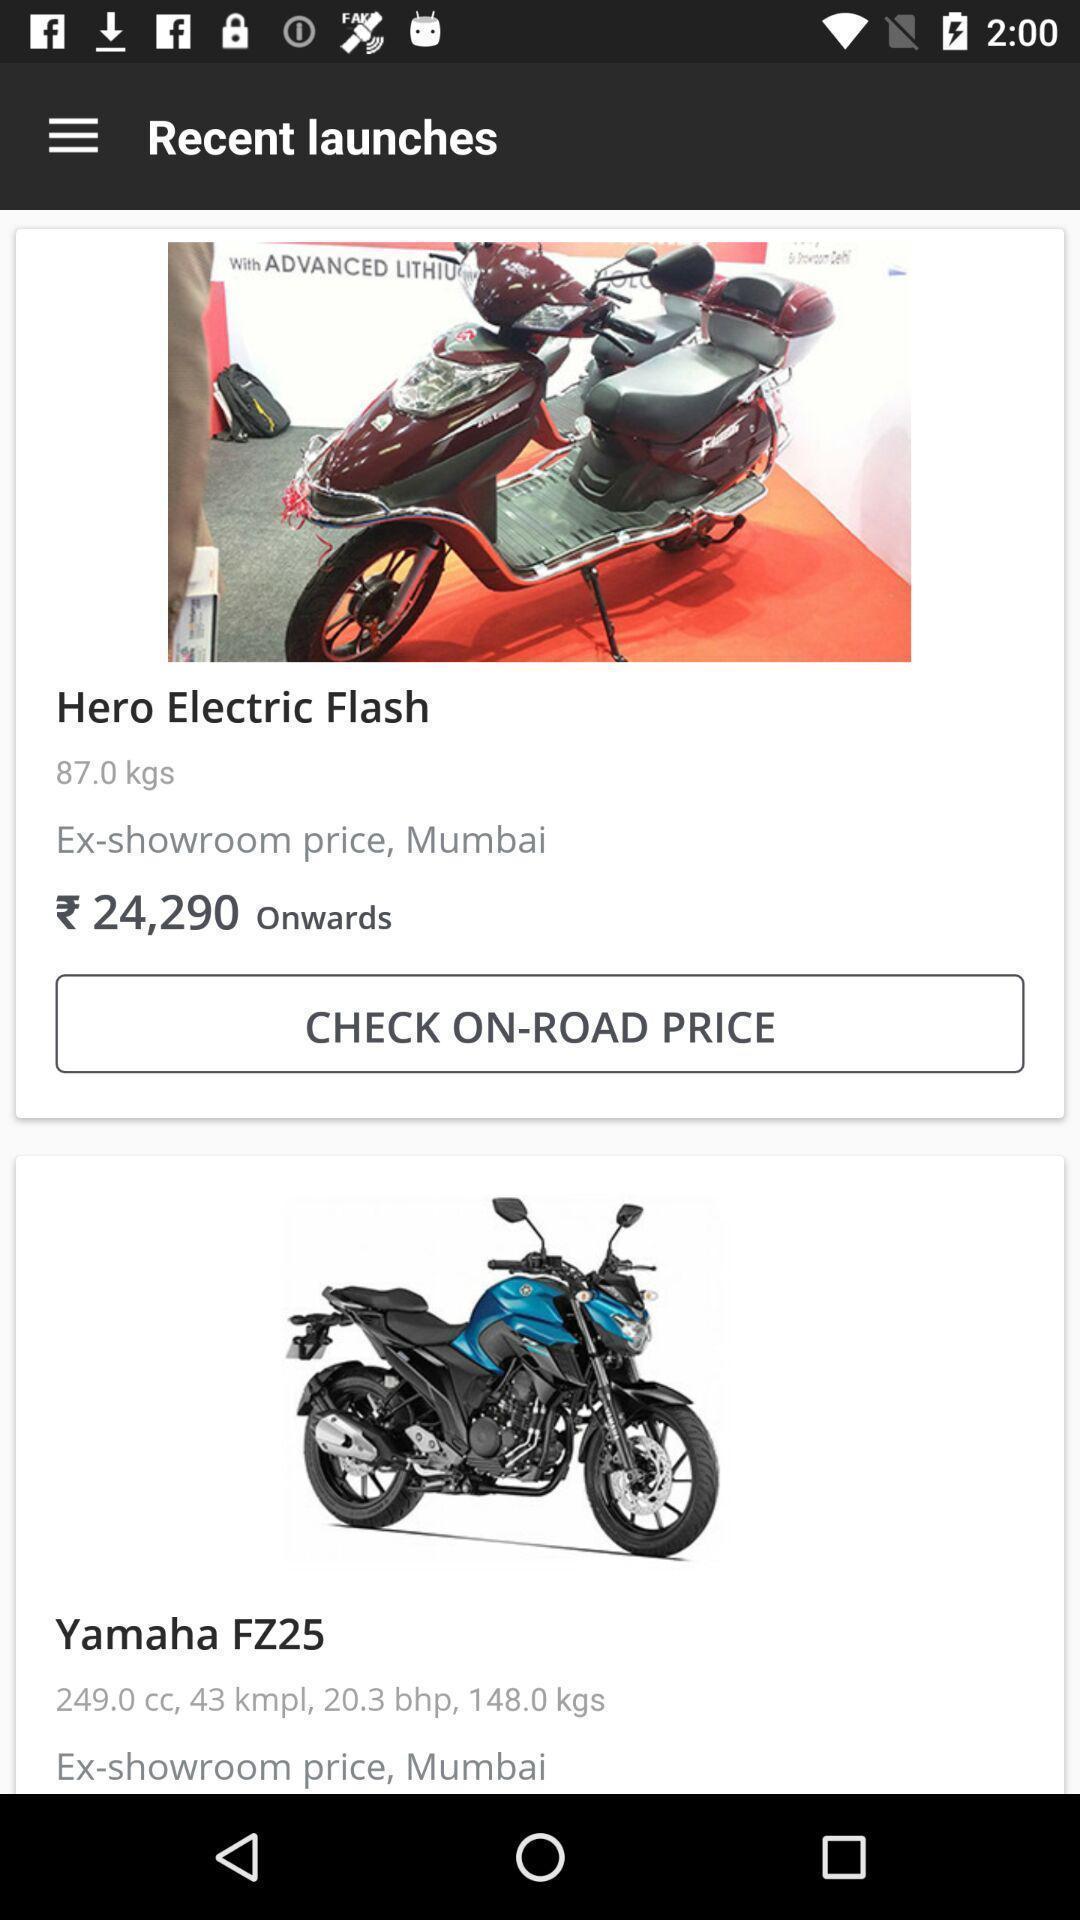What can you discern from this picture? Page displays recent launches in application. 